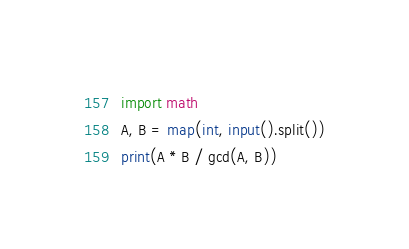<code> <loc_0><loc_0><loc_500><loc_500><_Python_>import math
A, B = map(int, input().split())
print(A * B / gcd(A, B))
</code> 